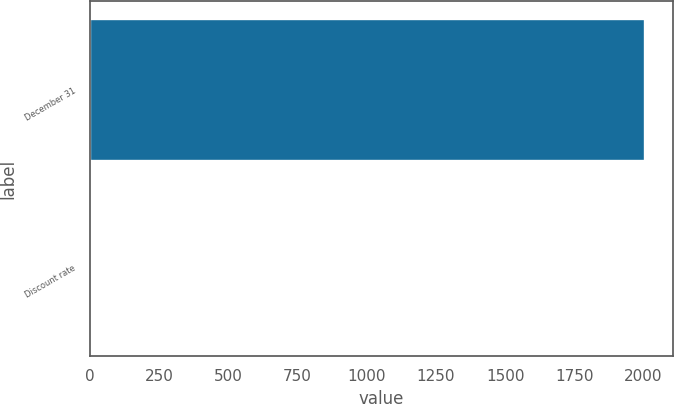Convert chart. <chart><loc_0><loc_0><loc_500><loc_500><bar_chart><fcel>December 31<fcel>Discount rate<nl><fcel>2007<fcel>6<nl></chart> 